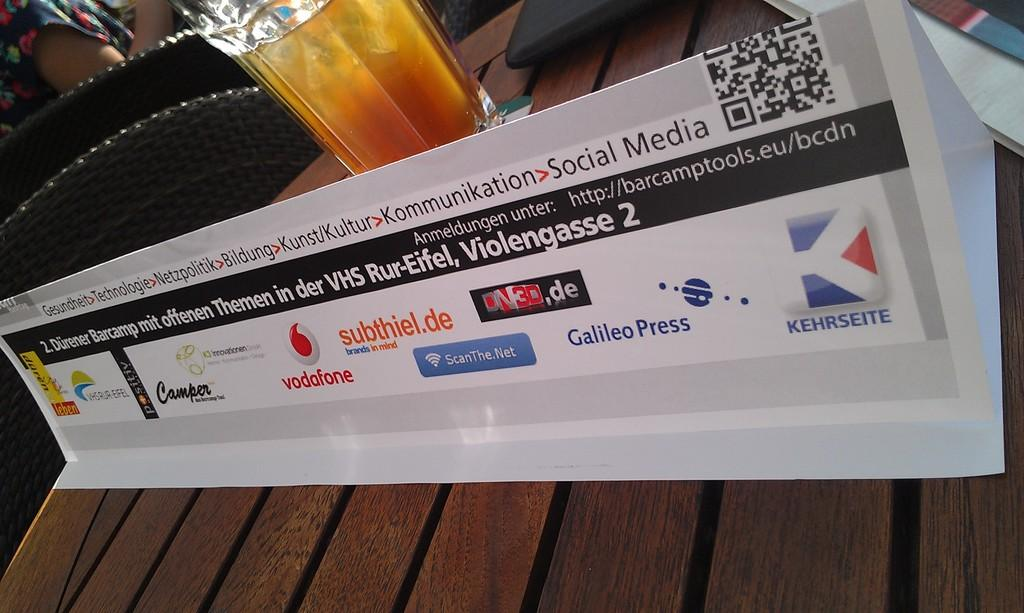<image>
Offer a succinct explanation of the picture presented. A banner sits on a table that bears the logs of several companies including Galileo Press 